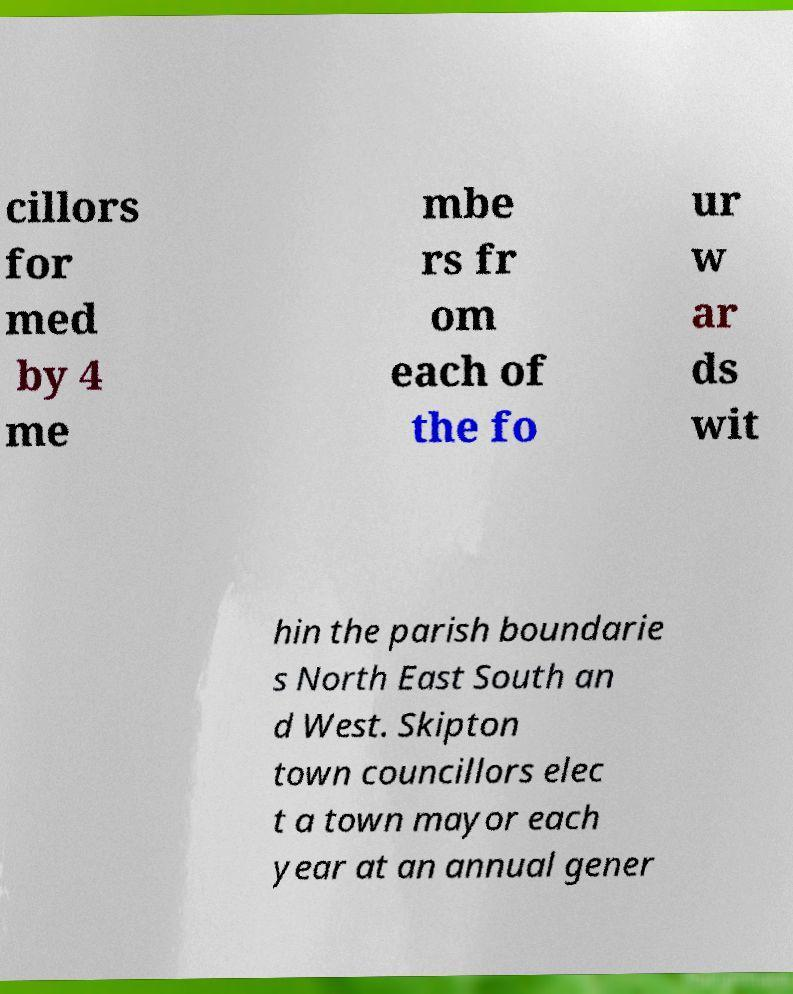Can you accurately transcribe the text from the provided image for me? cillors for med by 4 me mbe rs fr om each of the fo ur w ar ds wit hin the parish boundarie s North East South an d West. Skipton town councillors elec t a town mayor each year at an annual gener 